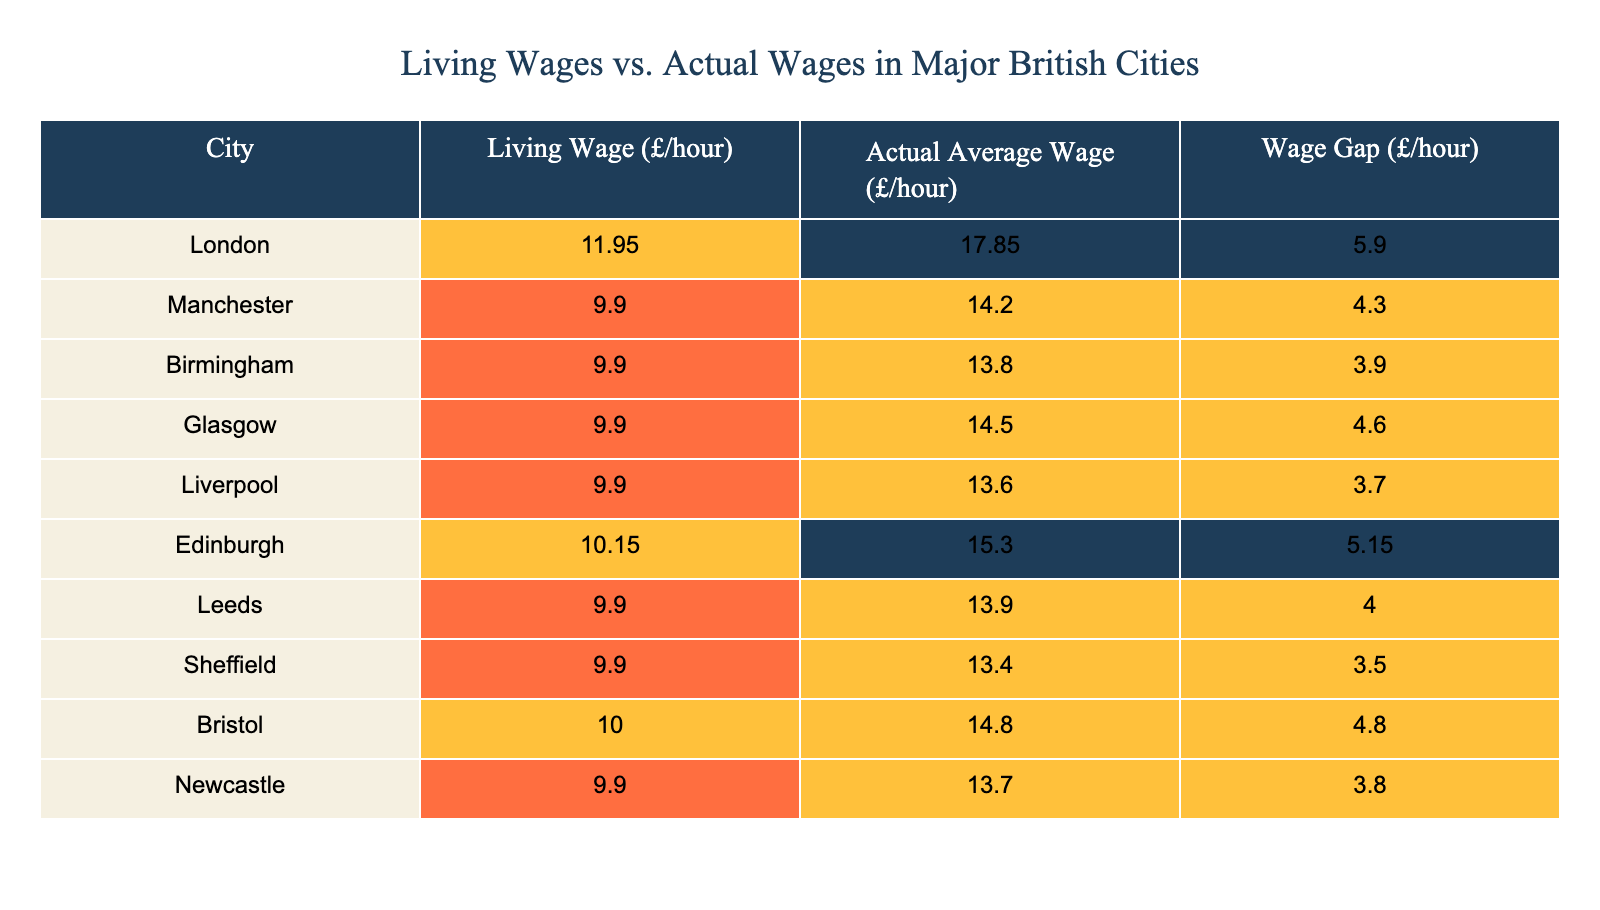What is the living wage in Birmingham? The living wage is listed in the table under the column "Living Wage (£/hour)" for Birmingham. Referring to that row, it shows £9.90 per hour.
Answer: £9.90 Which city has the largest wage gap? The wage gap is found in the column "Wage Gap (£/hour)". Comparing the values, London has the highest gap of £5.90.
Answer: London What is the average actual wage of all the cities listed? To find the average actual wage, sum the actual wages: (17.85 + 14.20 + 13.80 + 14.50 + 13.60 + 15.30 + 13.90 + 13.40 + 14.80 + 13.70) =  141.95. There are 10 cities, so the average is 141.95/10 = 14.195, approximately £14.20.
Answer: £14.20 Is the actual average wage in Liverpool greater than the living wage in Glasgow? The actual average wage in Liverpool is £13.60, and the living wage in Glasgow is £9.90. Since £13.60 is greater than £9.90, the answer is yes.
Answer: Yes How much is the total wage gap across all cities? To find the total wage gap, sum the wage gaps for each city: (5.90 + 4.30 + 3.90 + 4.60 + 3.70 + 5.15 + 4.00 + 3.50 + 4.80 + 3.80) = 43.65. The total wage gap across all cities is £43.65.
Answer: £43.65 Which city has the highest actual average wage? Referring to the "Actual Average Wage (£/hour)" column, London shows the highest value at £17.85.
Answer: London Are the actual average wages in Manchester and Birmingham both above £13? The actual average wage in Manchester is £14.20, and in Birmingham, it is £13.80. Both values exceed £13, so the answer is yes.
Answer: Yes What percentage of the living wage does the actual wage in Edinburgh represent? The actual wage in Edinburgh is £15.30, while the living wage is £10.15. The percentage can be calculated as (15.30 / 10.15) * 100 = 150.74%, indicating that the actual wage is about 150.74% of the living wage.
Answer: 150.74% 